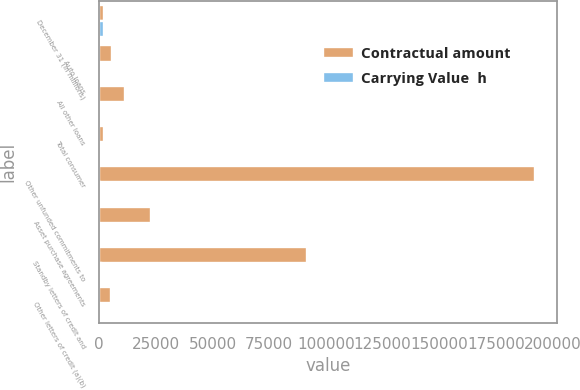<chart> <loc_0><loc_0><loc_500><loc_500><stacked_bar_chart><ecel><fcel>December 31 (in millions)<fcel>Auto loans<fcel>All other loans<fcel>Total consumer<fcel>Other unfunded commitments to<fcel>Asset purchase agreements<fcel>Standby letters of credit and<fcel>Other letters of credit (a)(b)<nl><fcel>Contractual amount<fcel>2009<fcel>5467<fcel>11229<fcel>2009<fcel>192145<fcel>22685<fcel>91485<fcel>5167<nl><fcel>Carrying Value  h<fcel>2009<fcel>7<fcel>5<fcel>12<fcel>356<fcel>126<fcel>919<fcel>1<nl></chart> 